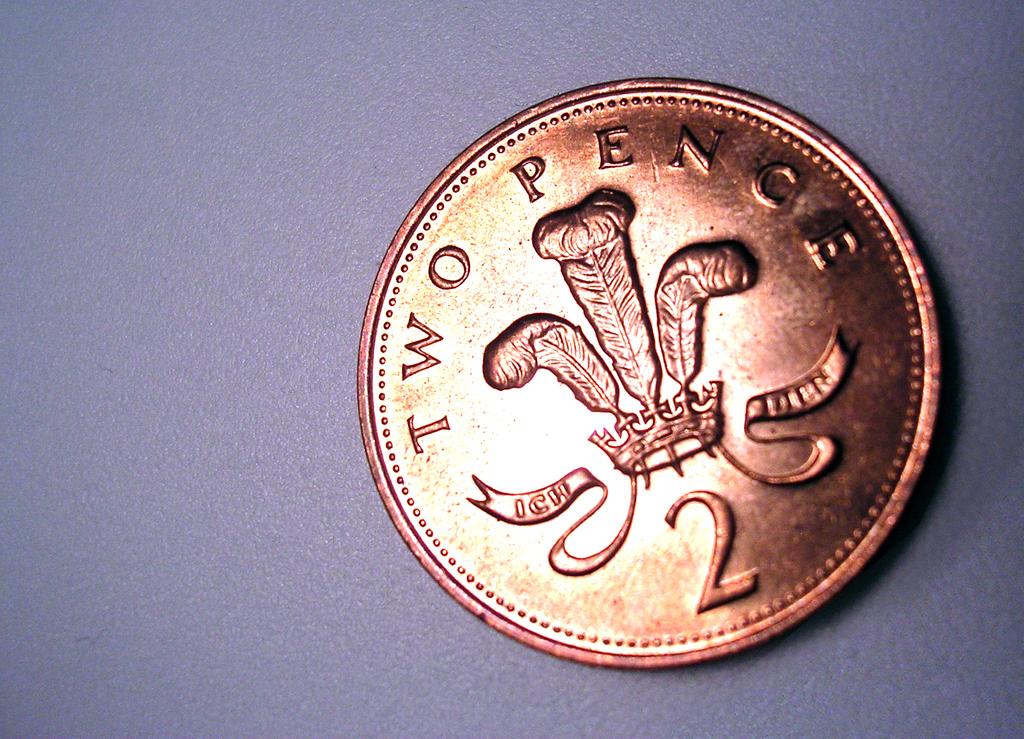How much is this coin worth?
Keep it short and to the point. Two pence. What kind of coin is this?
Keep it short and to the point. Two pence. 